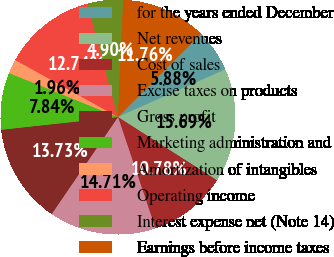Convert chart. <chart><loc_0><loc_0><loc_500><loc_500><pie_chart><fcel>for the years ended December<fcel>Net revenues<fcel>Cost of sales<fcel>Excise taxes on products<fcel>Gross profit<fcel>Marketing administration and<fcel>Amortization of intangibles<fcel>Operating income<fcel>Interest expense net (Note 14)<fcel>Earnings before income taxes<nl><fcel>5.88%<fcel>15.69%<fcel>10.78%<fcel>14.71%<fcel>13.73%<fcel>7.84%<fcel>1.96%<fcel>12.74%<fcel>4.9%<fcel>11.76%<nl></chart> 